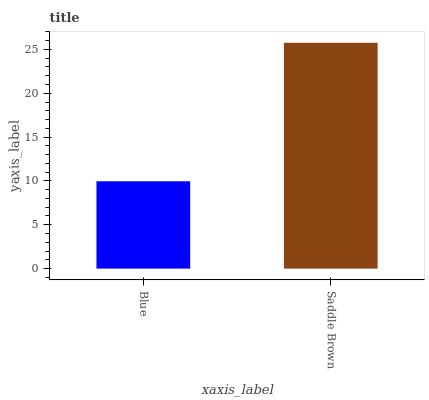Is Blue the minimum?
Answer yes or no. Yes. Is Saddle Brown the maximum?
Answer yes or no. Yes. Is Saddle Brown the minimum?
Answer yes or no. No. Is Saddle Brown greater than Blue?
Answer yes or no. Yes. Is Blue less than Saddle Brown?
Answer yes or no. Yes. Is Blue greater than Saddle Brown?
Answer yes or no. No. Is Saddle Brown less than Blue?
Answer yes or no. No. Is Saddle Brown the high median?
Answer yes or no. Yes. Is Blue the low median?
Answer yes or no. Yes. Is Blue the high median?
Answer yes or no. No. Is Saddle Brown the low median?
Answer yes or no. No. 